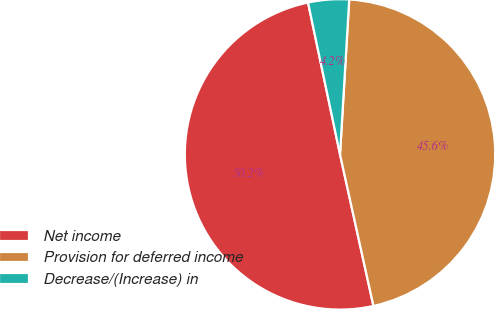<chart> <loc_0><loc_0><loc_500><loc_500><pie_chart><fcel>Net income<fcel>Provision for deferred income<fcel>Decrease/(Increase) in<nl><fcel>50.15%<fcel>45.6%<fcel>4.25%<nl></chart> 